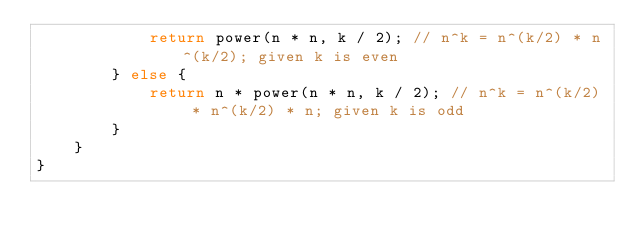Convert code to text. <code><loc_0><loc_0><loc_500><loc_500><_Java_>            return power(n * n, k / 2); // n^k = n^(k/2) * n^(k/2); given k is even
        } else {
            return n * power(n * n, k / 2); // n^k = n^(k/2) * n^(k/2) * n; given k is odd
        }
    }
}
</code> 